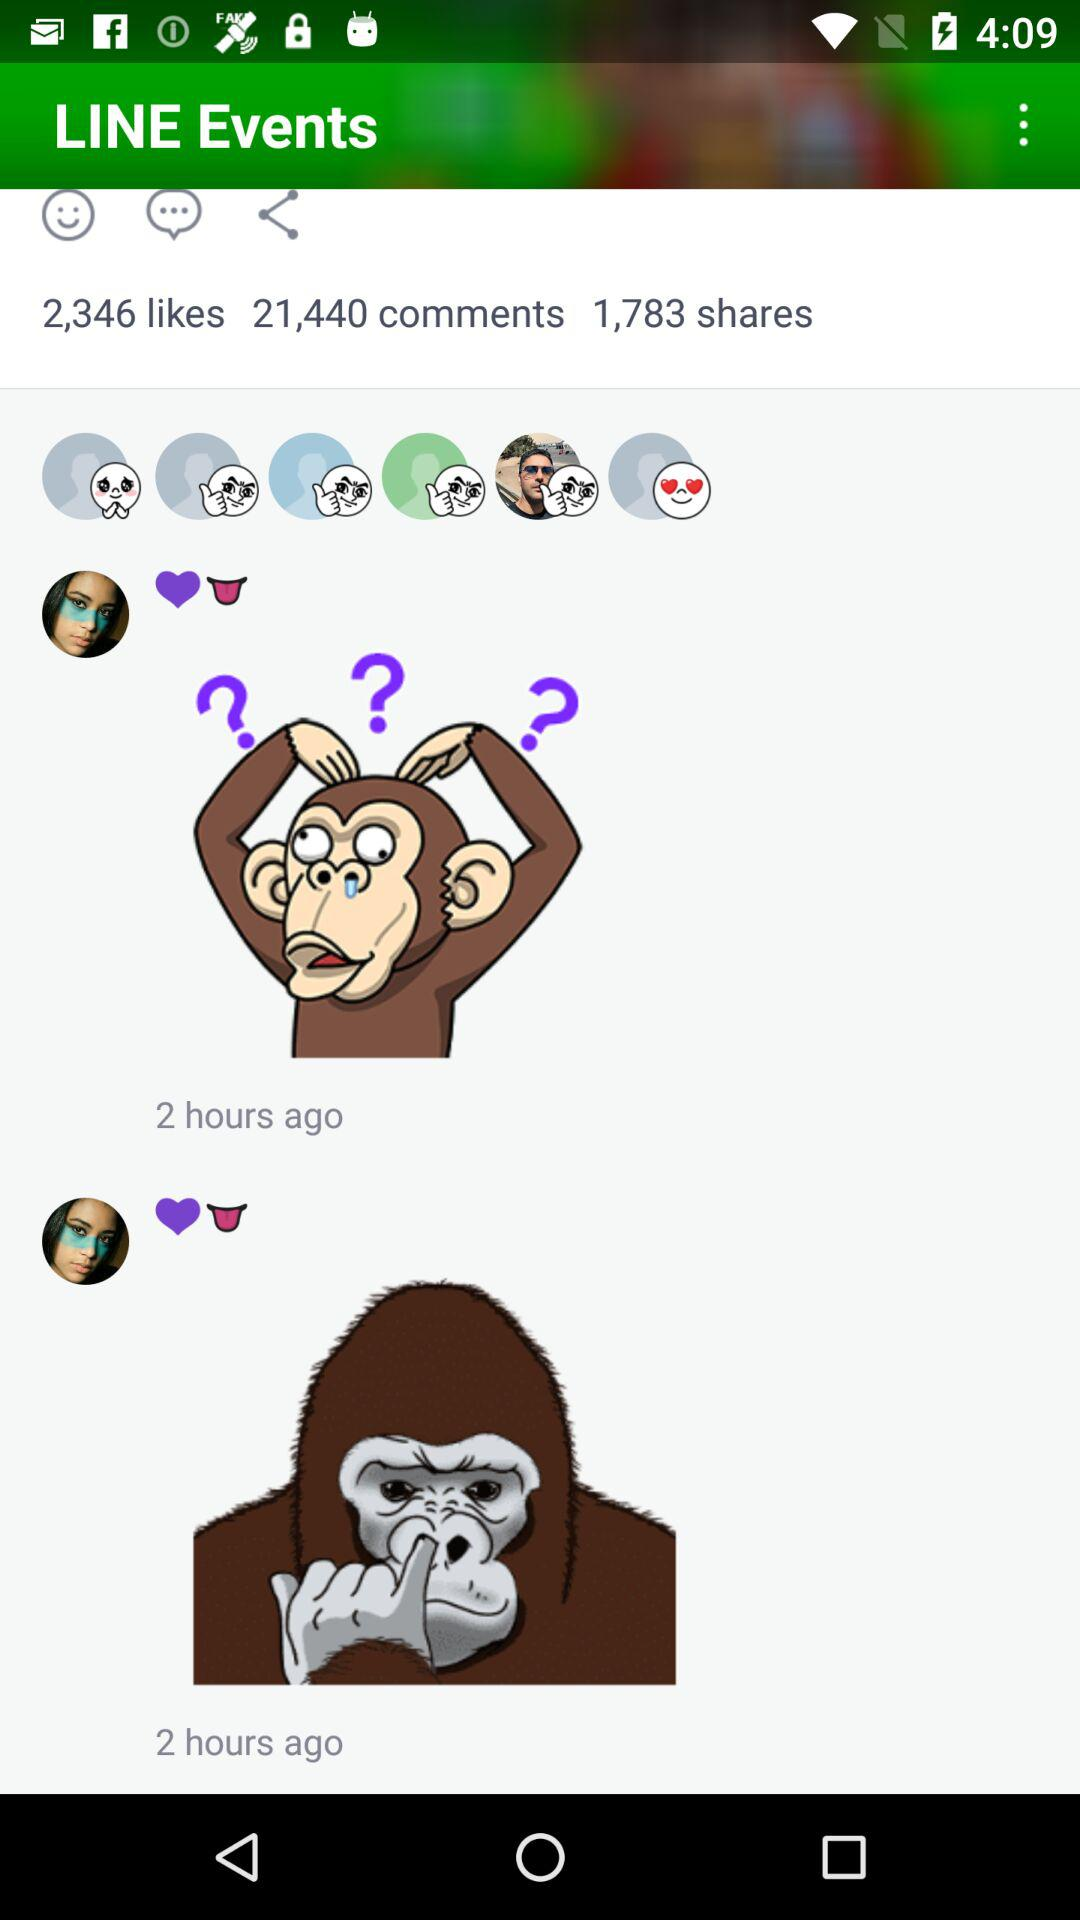How many stickers are there in the row of stickers?
Answer the question using a single word or phrase. 6 